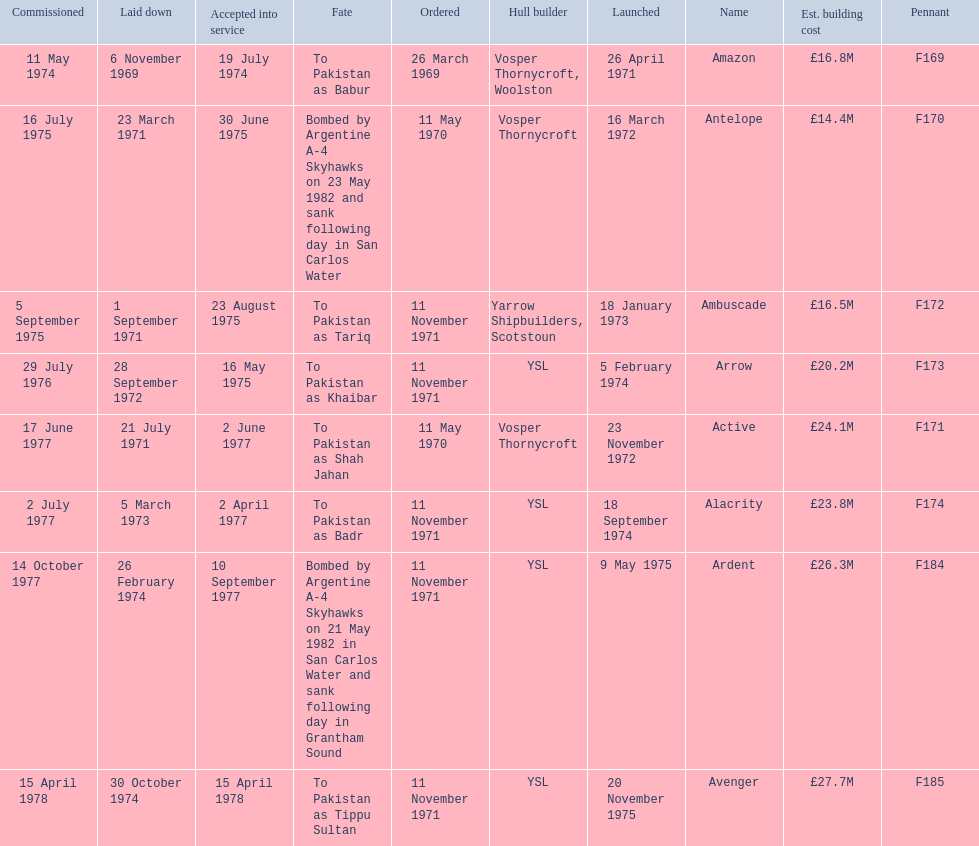What were the estimated building costs of the frigates? £16.8M, £14.4M, £16.5M, £20.2M, £24.1M, £23.8M, £26.3M, £27.7M. Which of these is the largest? £27.7M. What ship name does that correspond to? Avenger. 